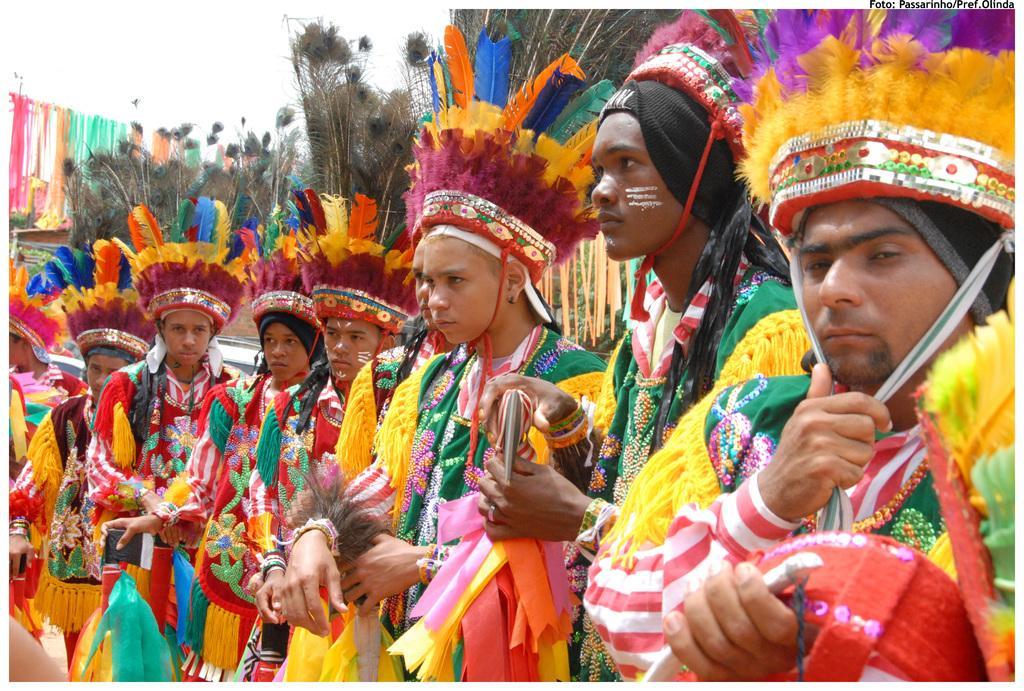Please provide a concise description of this image. In this picture we can see group of people, they wore costumes and we can see peacock feathers. 